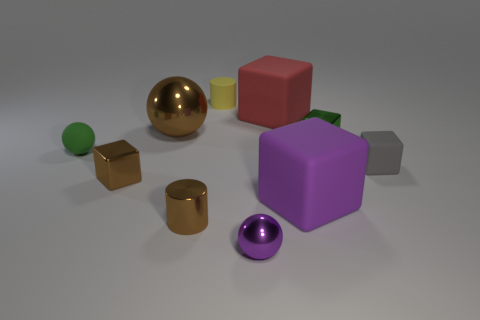What number of objects are things to the right of the large red matte thing or small rubber balls?
Ensure brevity in your answer.  4. Does the gray block have the same material as the tiny sphere that is behind the purple block?
Give a very brief answer. Yes. How many other objects are the same shape as the red thing?
Your response must be concise. 4. How many objects are shiny blocks in front of the gray rubber thing or tiny shiny blocks that are right of the red rubber object?
Provide a succinct answer. 2. What number of other things are the same color as the tiny metal ball?
Offer a very short reply. 1. Are there fewer rubber spheres behind the big ball than tiny things on the right side of the big red matte object?
Provide a short and direct response. Yes. How many small green rubber cylinders are there?
Give a very brief answer. 0. There is another big thing that is the same shape as the big purple matte thing; what is its material?
Your answer should be very brief. Rubber. Is the number of tiny brown blocks that are in front of the small purple metallic object less than the number of red rubber cylinders?
Provide a succinct answer. No. Is the shape of the rubber object in front of the small gray object the same as  the big brown object?
Provide a succinct answer. No. 